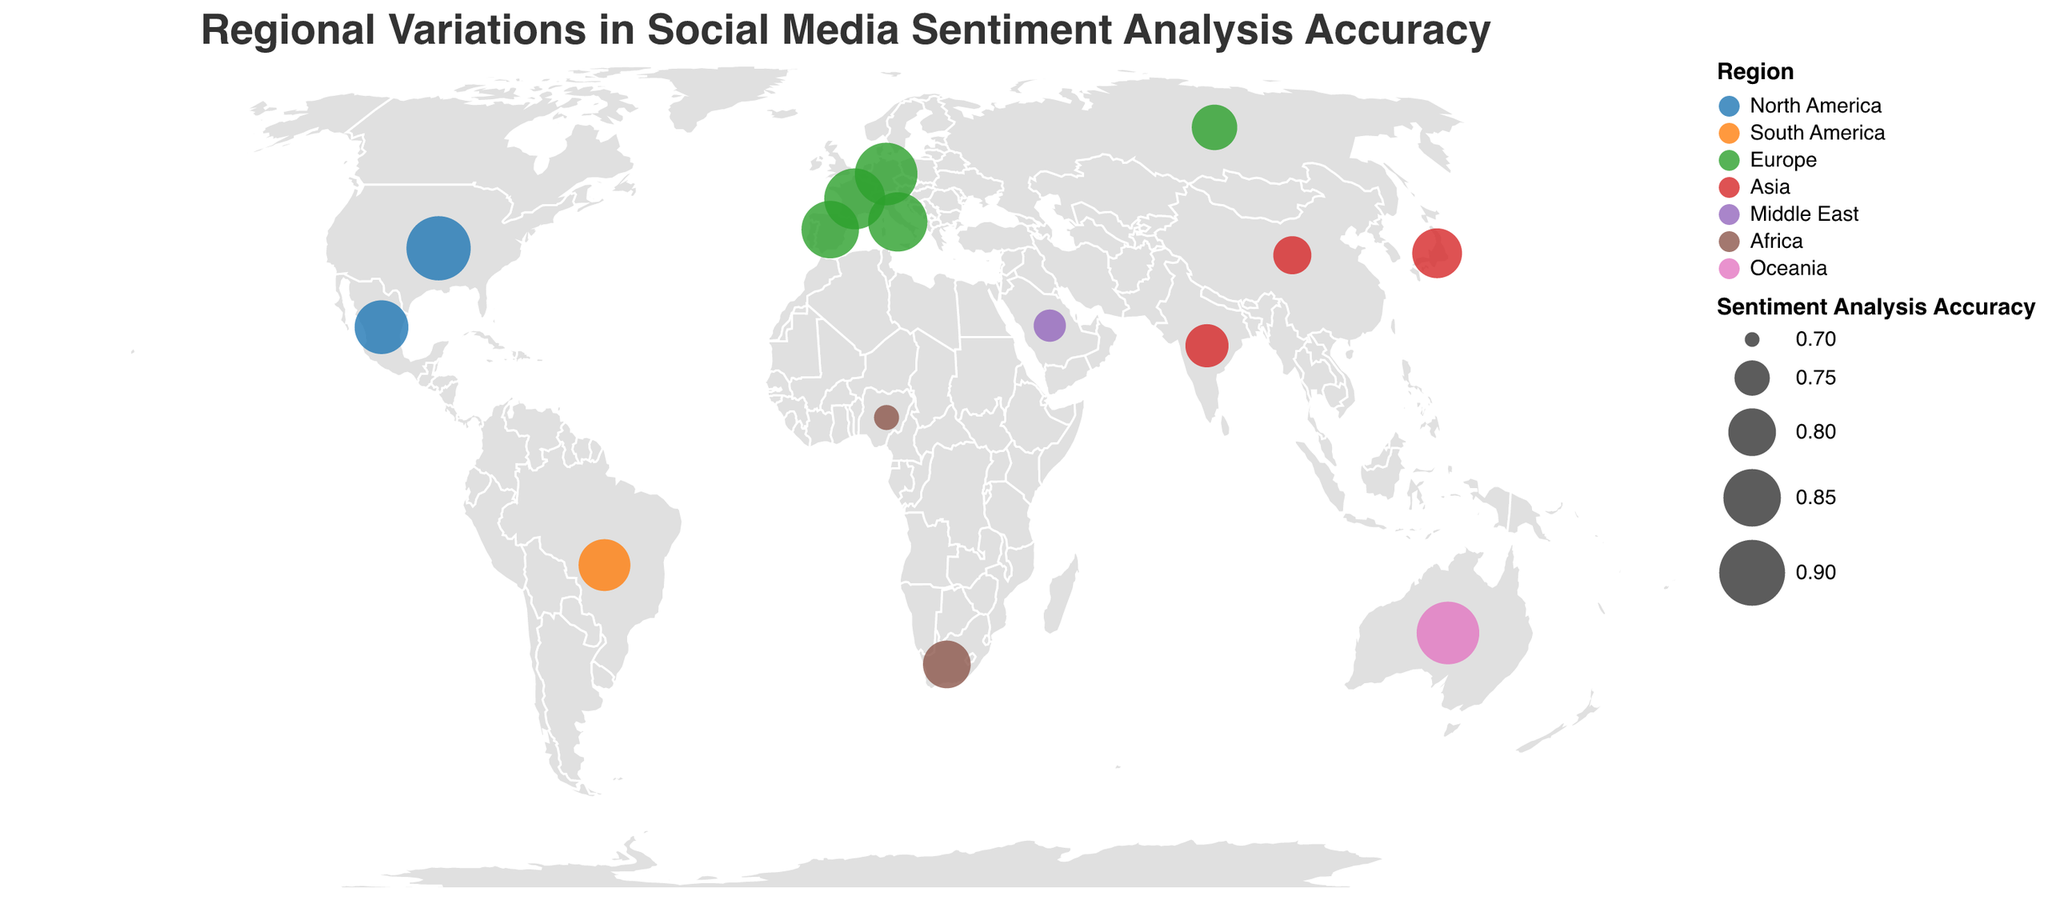What is the title of the figure? The title is displayed at the top of the figure and reads: "Regional Variations in Social Media Sentiment Analysis Accuracy".
Answer: Regional Variations in Social Media Sentiment Analysis Accuracy Which country has the highest sentiment analysis accuracy? Looking at the size of the circles, the biggest circle corresponds to the United States with a sentiment accuracy of 0.89.
Answer: United States Which region has the lowest average sentiment analysis accuracy? By calculating the average accuracy for each region, we find: North America (0.86), South America (0.82), Europe (0.85), Asia (0.78), Middle East (0.74), Africa (0.76), Oceania (0.88). The Middle East has the lowest average accuracy at 0.74.
Answer: Middle East What is the sentiment accuracy in Japan and how does it compare to that in China? Japan has a sentiment accuracy of 0.81, while China has a sentiment accuracy of 0.76. Japan's accuracy is higher.
Answer: Japan has higher accuracy Which languages are used in countries within the Europe region? The Europe region includes Spain, France, Germany, Russia, and Italy. The languages are Spanish, French, German, Russian, and Italian.
Answer: Spanish, French, German, Russian, Italian Are there any countries in the Oceania region? If so, which one and what is its sentiment accuracy? The figure shows a country in Oceania, which is Australia, with a sentiment accuracy of 0.88.
Answer: Australia, 0.88 Compare the sentiment analysis accuracies between North American countries. North America includes the United States (0.89) and Mexico (0.83). The United States has a higher accuracy compared to Mexico.
Answer: United States has higher accuracy What regions use Arabic and Yoruba languages, and what is their sentiment accuracy? Arabic is used in Saudi Arabia (Middle East) with a sentiment accuracy of 0.74, and Yoruba is used in Nigeria (Africa) with an accuracy of 0.72.
Answer: Saudi Arabia (0.74), Nigeria (0.72) What is the average sentiment accuracy for countries in Asia? Countries in Asia are China (0.76), Japan (0.81), and India (0.78). The average accuracy is calculated as (0.76 + 0.81 + 0.78) / 3 = 0.7833.
Answer: 0.783 What is the main insight from comparing sentiment accuracies across different regions? The plot shows that sentiment accuracies vary by region, with North America and Oceania generally having higher accuracies, while Middle East and Africa have lower accuracies. This could imply differences in language processing effectiveness across regions.
Answer: North America, Oceania higher; Middle East, Africa lower 